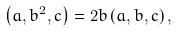<formula> <loc_0><loc_0><loc_500><loc_500>\left ( a , b ^ { 2 } , c \right ) = 2 b \left ( a , b , c \right ) ,</formula> 